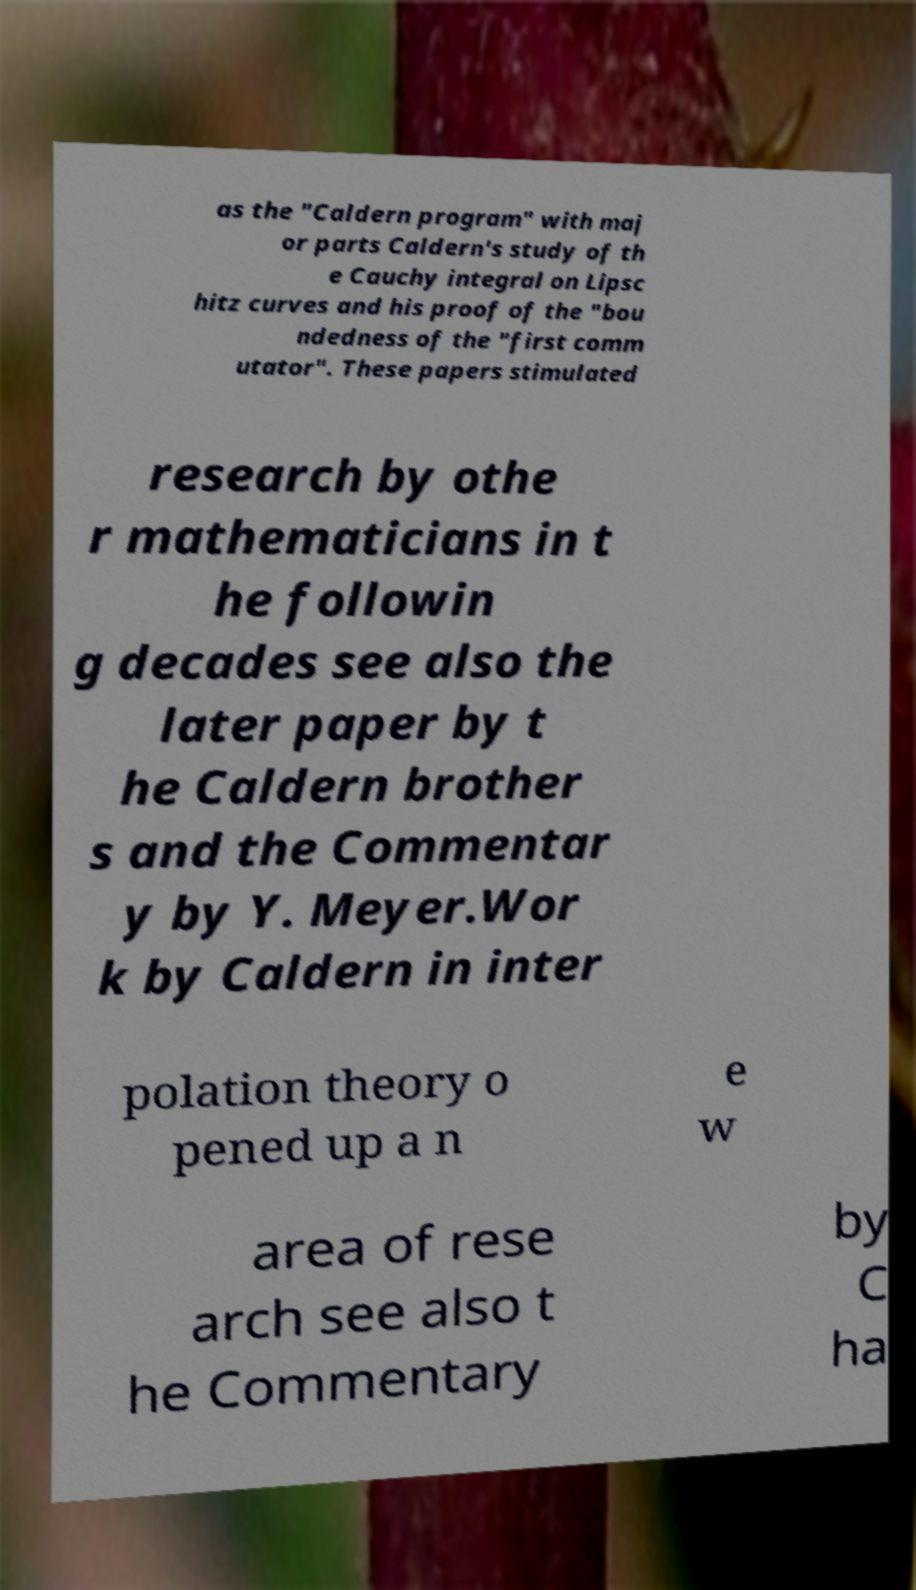Could you extract and type out the text from this image? as the "Caldern program" with maj or parts Caldern's study of th e Cauchy integral on Lipsc hitz curves and his proof of the "bou ndedness of the "first comm utator". These papers stimulated research by othe r mathematicians in t he followin g decades see also the later paper by t he Caldern brother s and the Commentar y by Y. Meyer.Wor k by Caldern in inter polation theory o pened up a n e w area of rese arch see also t he Commentary by C ha 